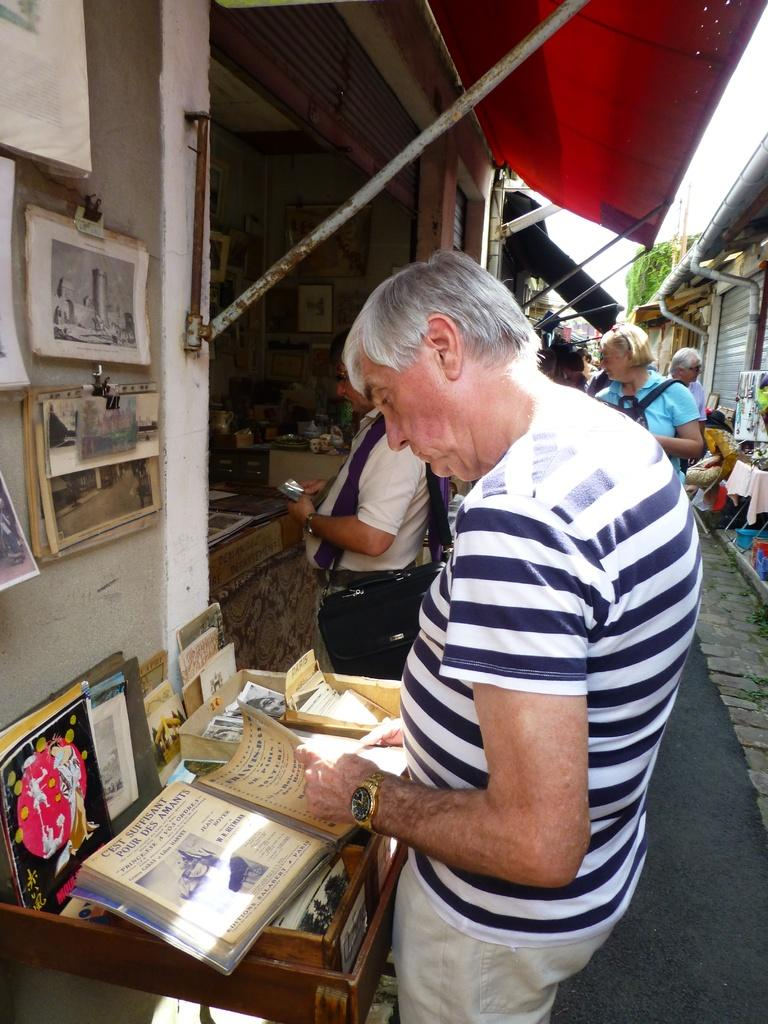How many people are in the image? There are persons in the image. What is the primary object in the image? There is a table in the image. What type of items can be seen on the table? There are books in the image. What material is present in the image? There is cloth in the image. What architectural feature is visible in the image? There are shutters in the image. What else can be found in the image? There are objects in the image. What is the background of the image? There is a wall in the image, and the sky is visible in the background. Can you tell me how many women are depicted in the image? The provided facts do not mention any women in the image. How much does the dime cost in the image? There is no mention of a dime in the image. 